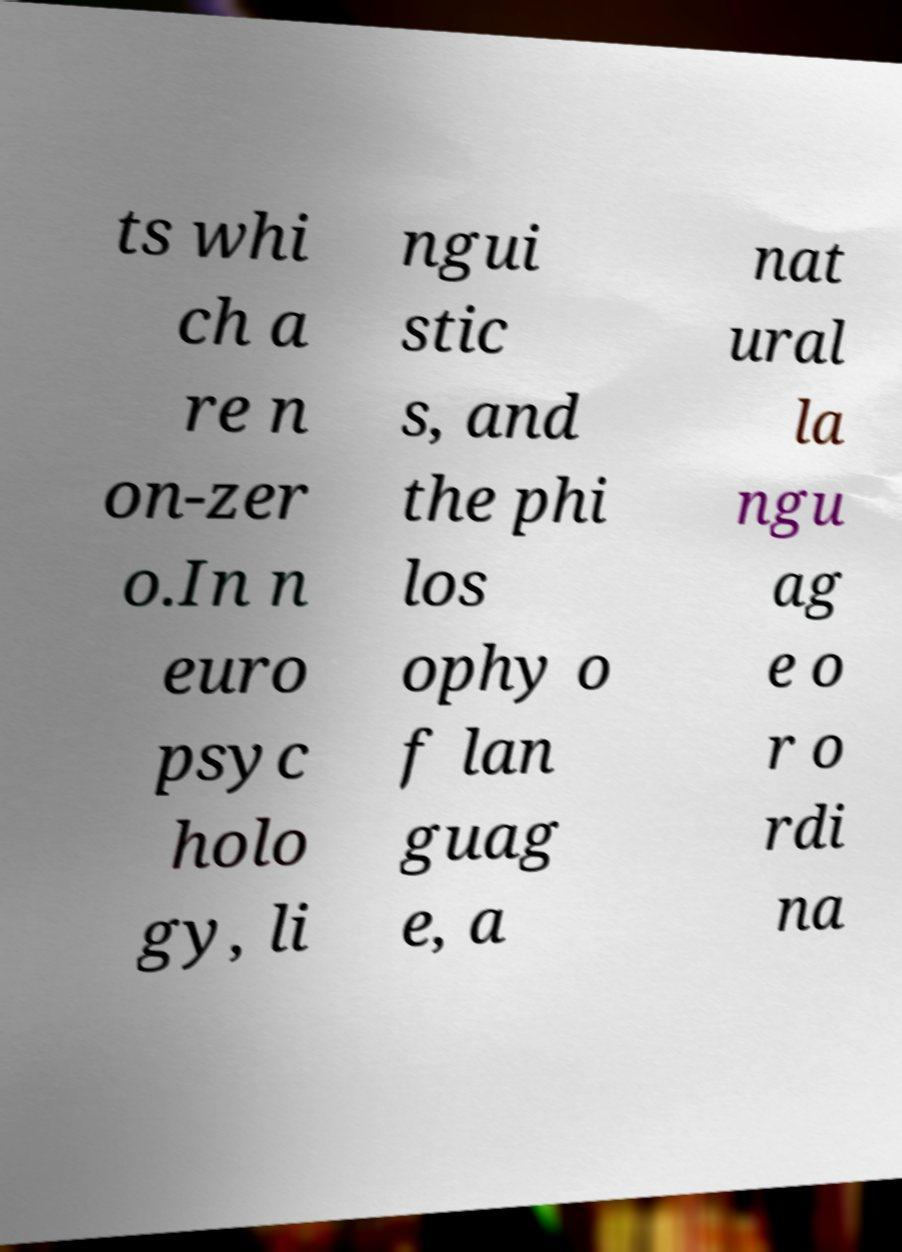Could you extract and type out the text from this image? ts whi ch a re n on-zer o.In n euro psyc holo gy, li ngui stic s, and the phi los ophy o f lan guag e, a nat ural la ngu ag e o r o rdi na 